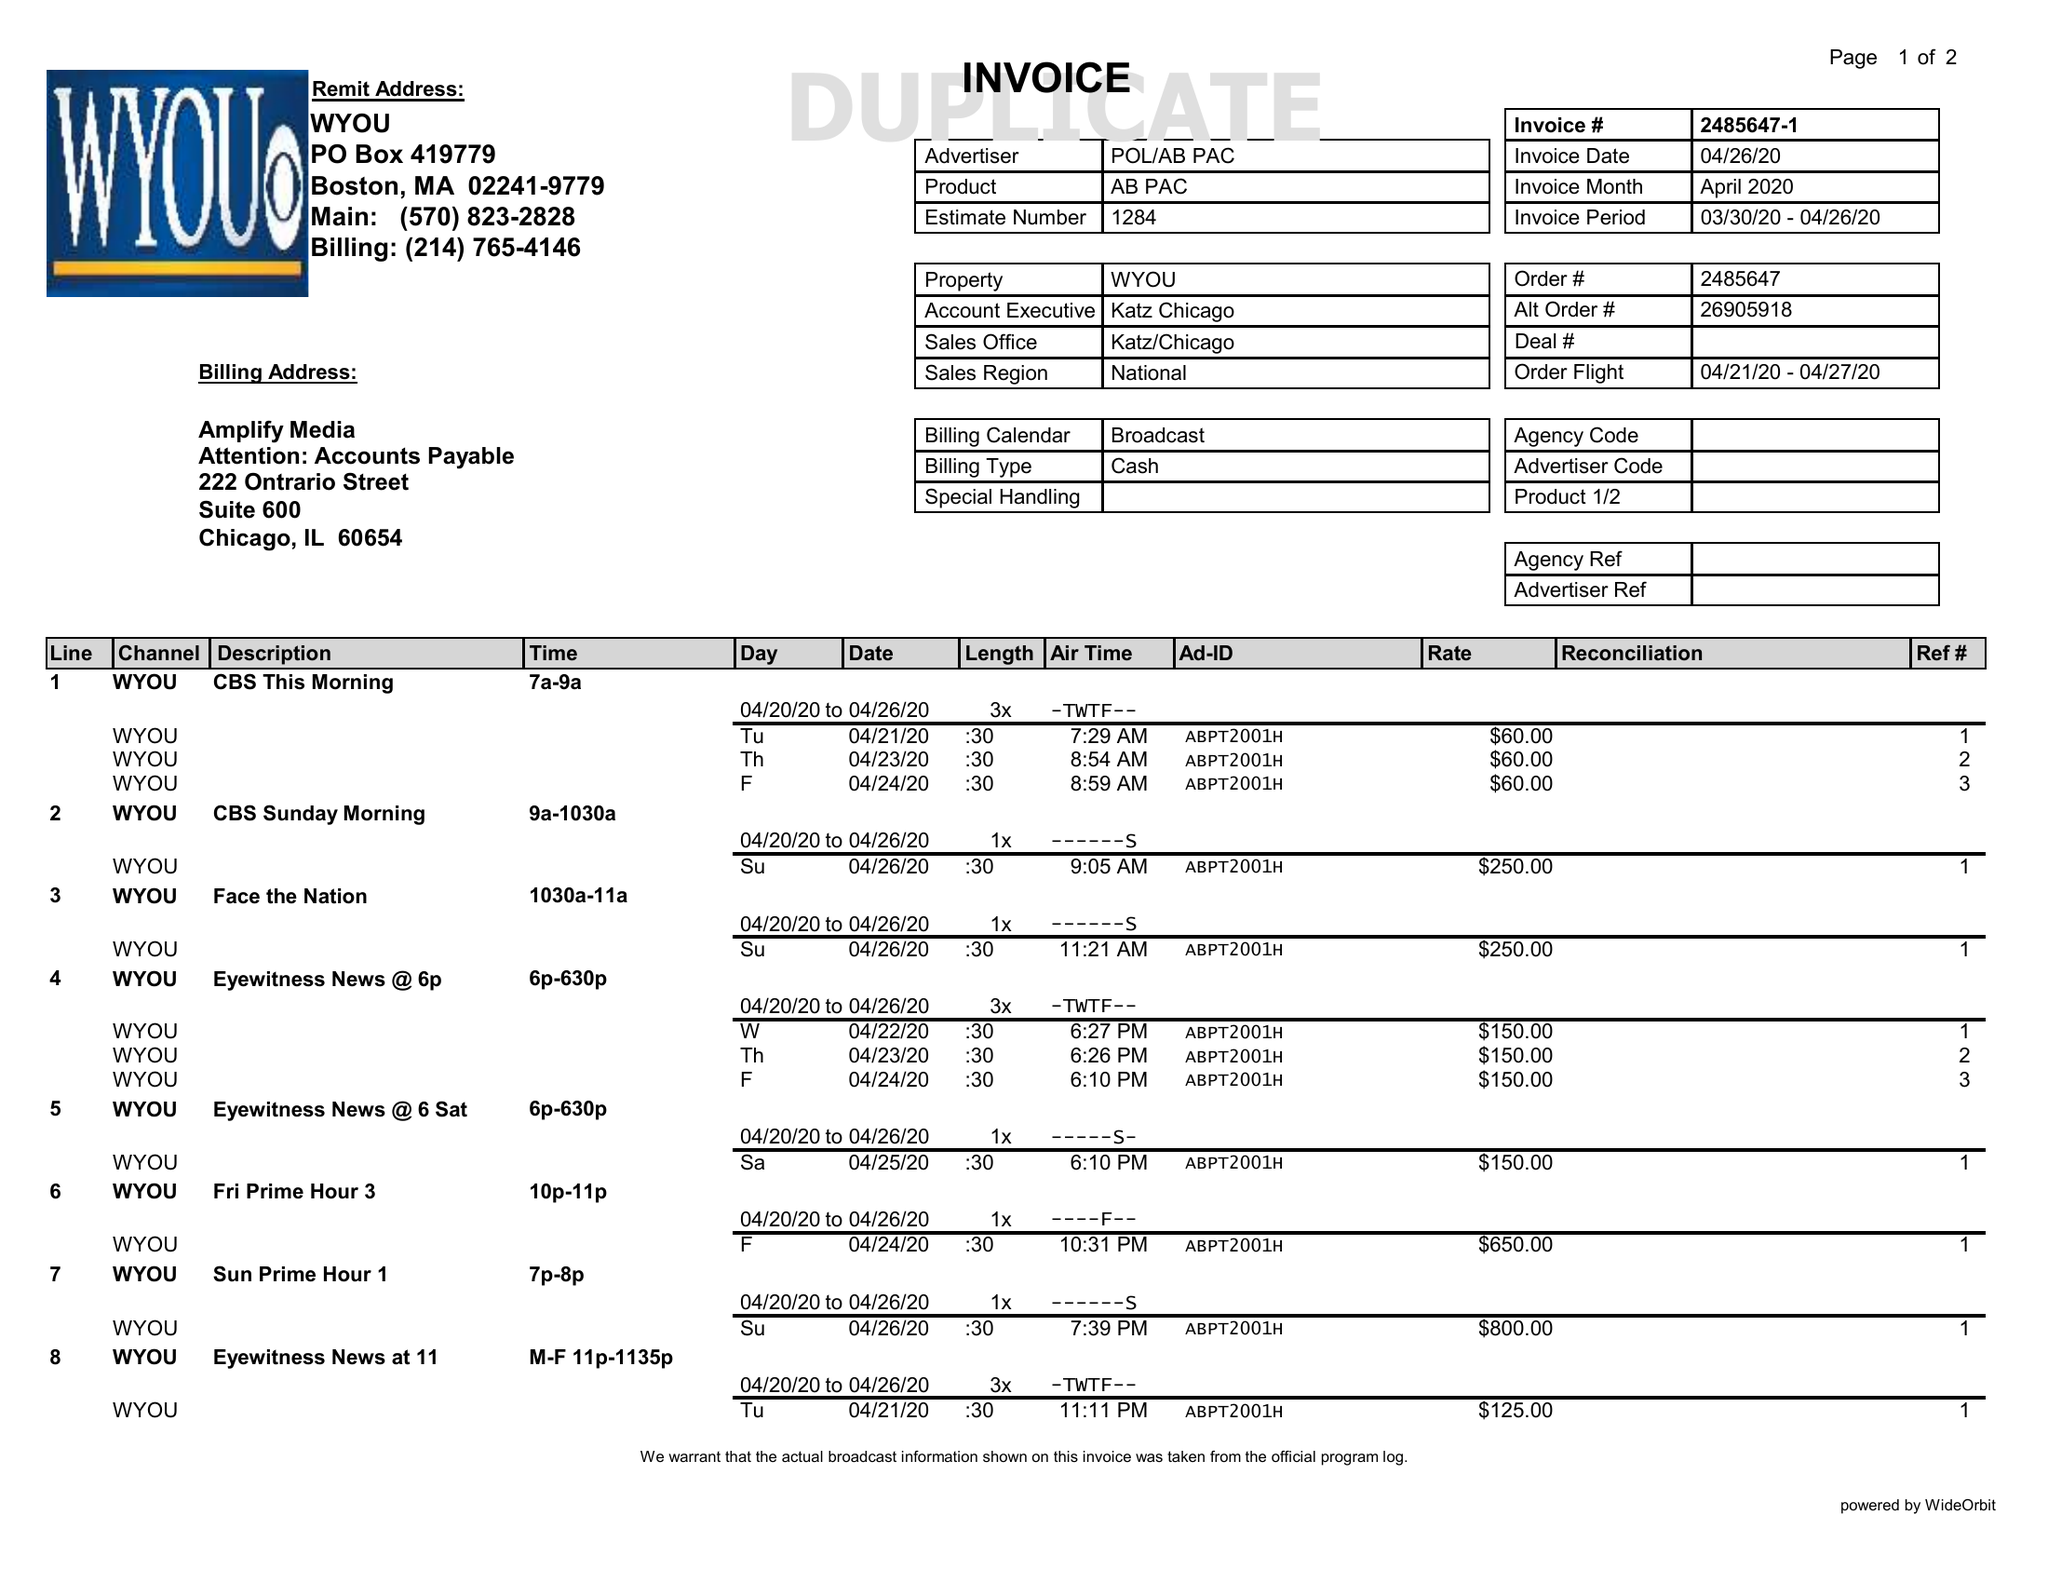What is the value for the flight_to?
Answer the question using a single word or phrase. 04/27/20 